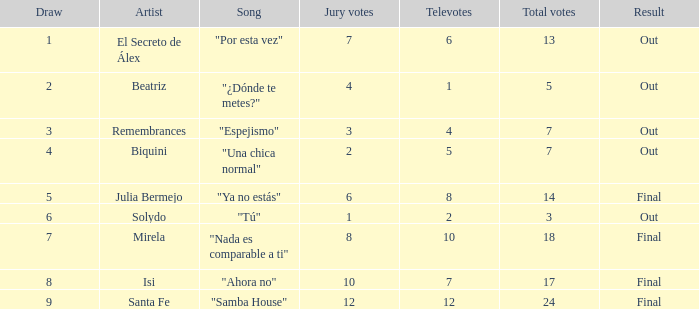Name the number of song for solydo 1.0. 